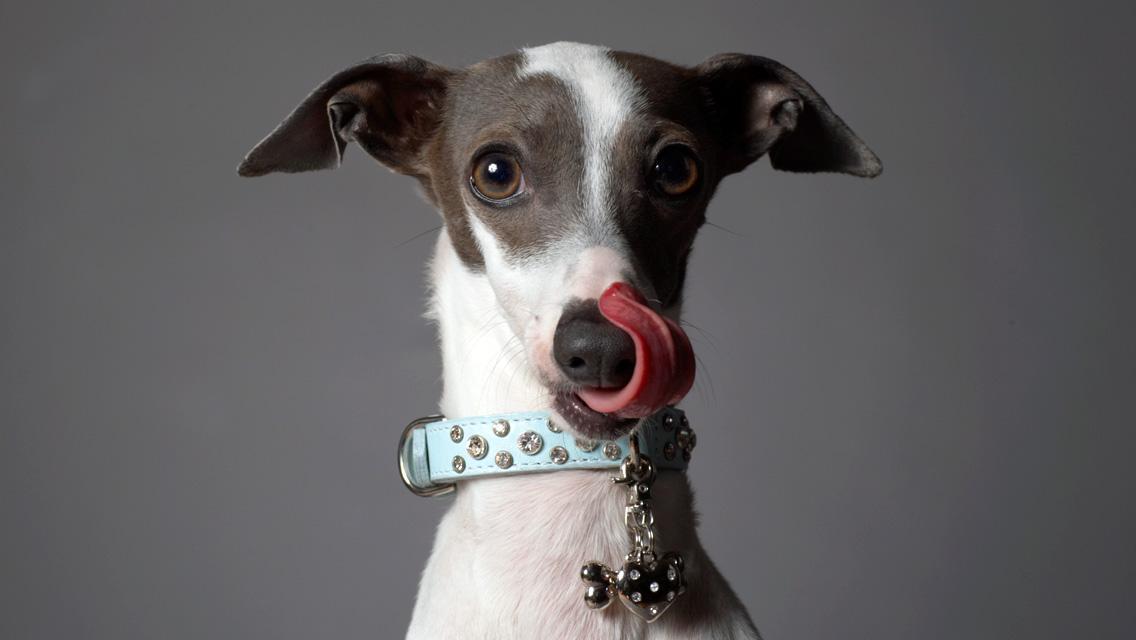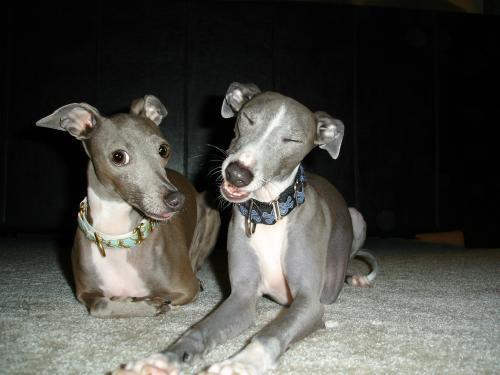The first image is the image on the left, the second image is the image on the right. Considering the images on both sides, is "There are more dogs in the right image than in the left." valid? Answer yes or no. Yes. The first image is the image on the left, the second image is the image on the right. For the images shown, is this caption "All dogs are wearing fancy, colorful collars." true? Answer yes or no. Yes. 